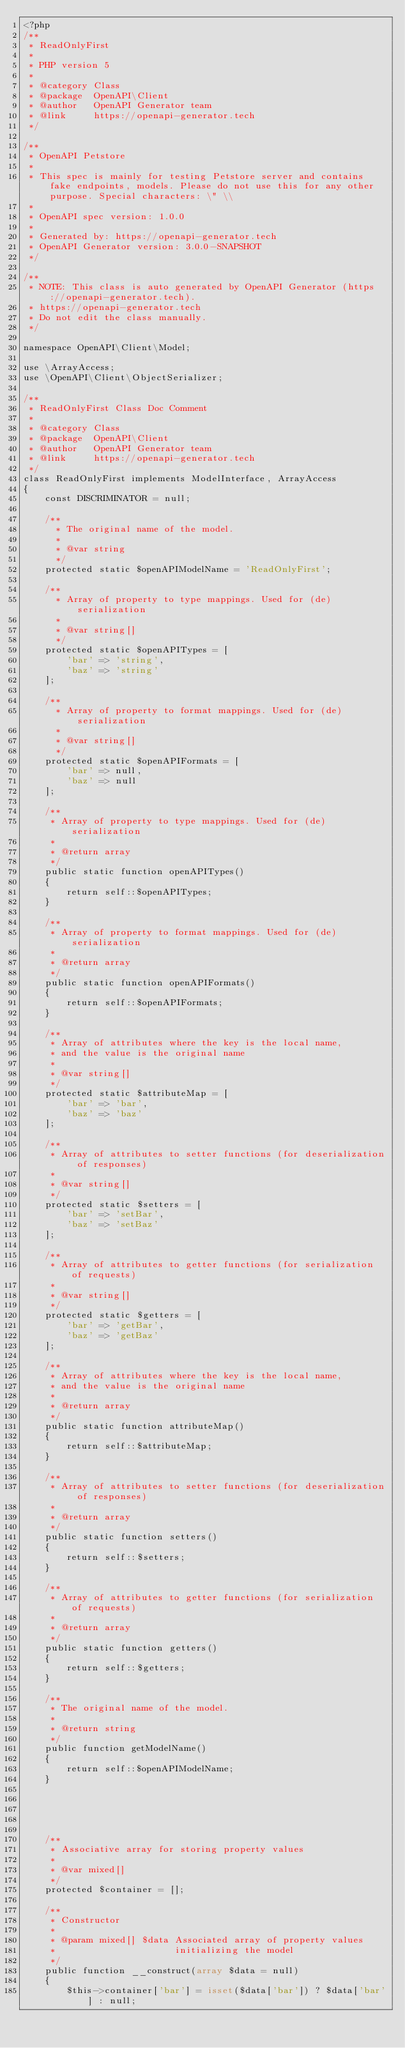<code> <loc_0><loc_0><loc_500><loc_500><_PHP_><?php
/**
 * ReadOnlyFirst
 *
 * PHP version 5
 *
 * @category Class
 * @package  OpenAPI\Client
 * @author   OpenAPI Generator team
 * @link     https://openapi-generator.tech
 */

/**
 * OpenAPI Petstore
 *
 * This spec is mainly for testing Petstore server and contains fake endpoints, models. Please do not use this for any other purpose. Special characters: \" \\
 *
 * OpenAPI spec version: 1.0.0
 * 
 * Generated by: https://openapi-generator.tech
 * OpenAPI Generator version: 3.0.0-SNAPSHOT
 */

/**
 * NOTE: This class is auto generated by OpenAPI Generator (https://openapi-generator.tech).
 * https://openapi-generator.tech
 * Do not edit the class manually.
 */

namespace OpenAPI\Client\Model;

use \ArrayAccess;
use \OpenAPI\Client\ObjectSerializer;

/**
 * ReadOnlyFirst Class Doc Comment
 *
 * @category Class
 * @package  OpenAPI\Client
 * @author   OpenAPI Generator team
 * @link     https://openapi-generator.tech
 */
class ReadOnlyFirst implements ModelInterface, ArrayAccess
{
    const DISCRIMINATOR = null;

    /**
      * The original name of the model.
      *
      * @var string
      */
    protected static $openAPIModelName = 'ReadOnlyFirst';

    /**
      * Array of property to type mappings. Used for (de)serialization
      *
      * @var string[]
      */
    protected static $openAPITypes = [
        'bar' => 'string',
        'baz' => 'string'
    ];

    /**
      * Array of property to format mappings. Used for (de)serialization
      *
      * @var string[]
      */
    protected static $openAPIFormats = [
        'bar' => null,
        'baz' => null
    ];

    /**
     * Array of property to type mappings. Used for (de)serialization
     *
     * @return array
     */
    public static function openAPITypes()
    {
        return self::$openAPITypes;
    }

    /**
     * Array of property to format mappings. Used for (de)serialization
     *
     * @return array
     */
    public static function openAPIFormats()
    {
        return self::$openAPIFormats;
    }

    /**
     * Array of attributes where the key is the local name,
     * and the value is the original name
     *
     * @var string[]
     */
    protected static $attributeMap = [
        'bar' => 'bar',
        'baz' => 'baz'
    ];

    /**
     * Array of attributes to setter functions (for deserialization of responses)
     *
     * @var string[]
     */
    protected static $setters = [
        'bar' => 'setBar',
        'baz' => 'setBaz'
    ];

    /**
     * Array of attributes to getter functions (for serialization of requests)
     *
     * @var string[]
     */
    protected static $getters = [
        'bar' => 'getBar',
        'baz' => 'getBaz'
    ];

    /**
     * Array of attributes where the key is the local name,
     * and the value is the original name
     *
     * @return array
     */
    public static function attributeMap()
    {
        return self::$attributeMap;
    }

    /**
     * Array of attributes to setter functions (for deserialization of responses)
     *
     * @return array
     */
    public static function setters()
    {
        return self::$setters;
    }

    /**
     * Array of attributes to getter functions (for serialization of requests)
     *
     * @return array
     */
    public static function getters()
    {
        return self::$getters;
    }

    /**
     * The original name of the model.
     *
     * @return string
     */
    public function getModelName()
    {
        return self::$openAPIModelName;
    }

    

    

    /**
     * Associative array for storing property values
     *
     * @var mixed[]
     */
    protected $container = [];

    /**
     * Constructor
     *
     * @param mixed[] $data Associated array of property values
     *                      initializing the model
     */
    public function __construct(array $data = null)
    {
        $this->container['bar'] = isset($data['bar']) ? $data['bar'] : null;</code> 